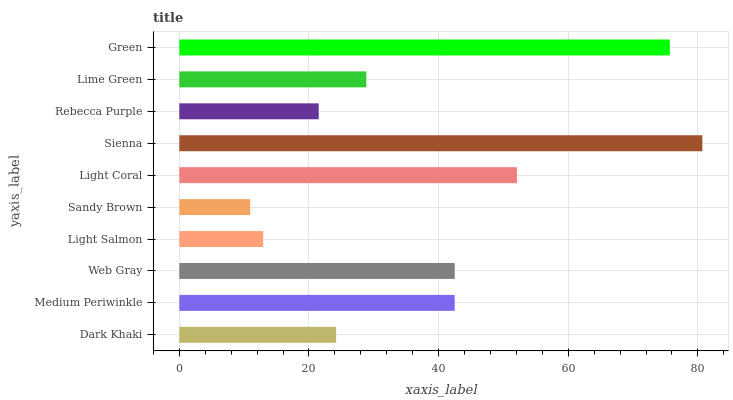Is Sandy Brown the minimum?
Answer yes or no. Yes. Is Sienna the maximum?
Answer yes or no. Yes. Is Medium Periwinkle the minimum?
Answer yes or no. No. Is Medium Periwinkle the maximum?
Answer yes or no. No. Is Medium Periwinkle greater than Dark Khaki?
Answer yes or no. Yes. Is Dark Khaki less than Medium Periwinkle?
Answer yes or no. Yes. Is Dark Khaki greater than Medium Periwinkle?
Answer yes or no. No. Is Medium Periwinkle less than Dark Khaki?
Answer yes or no. No. Is Medium Periwinkle the high median?
Answer yes or no. Yes. Is Lime Green the low median?
Answer yes or no. Yes. Is Light Coral the high median?
Answer yes or no. No. Is Web Gray the low median?
Answer yes or no. No. 